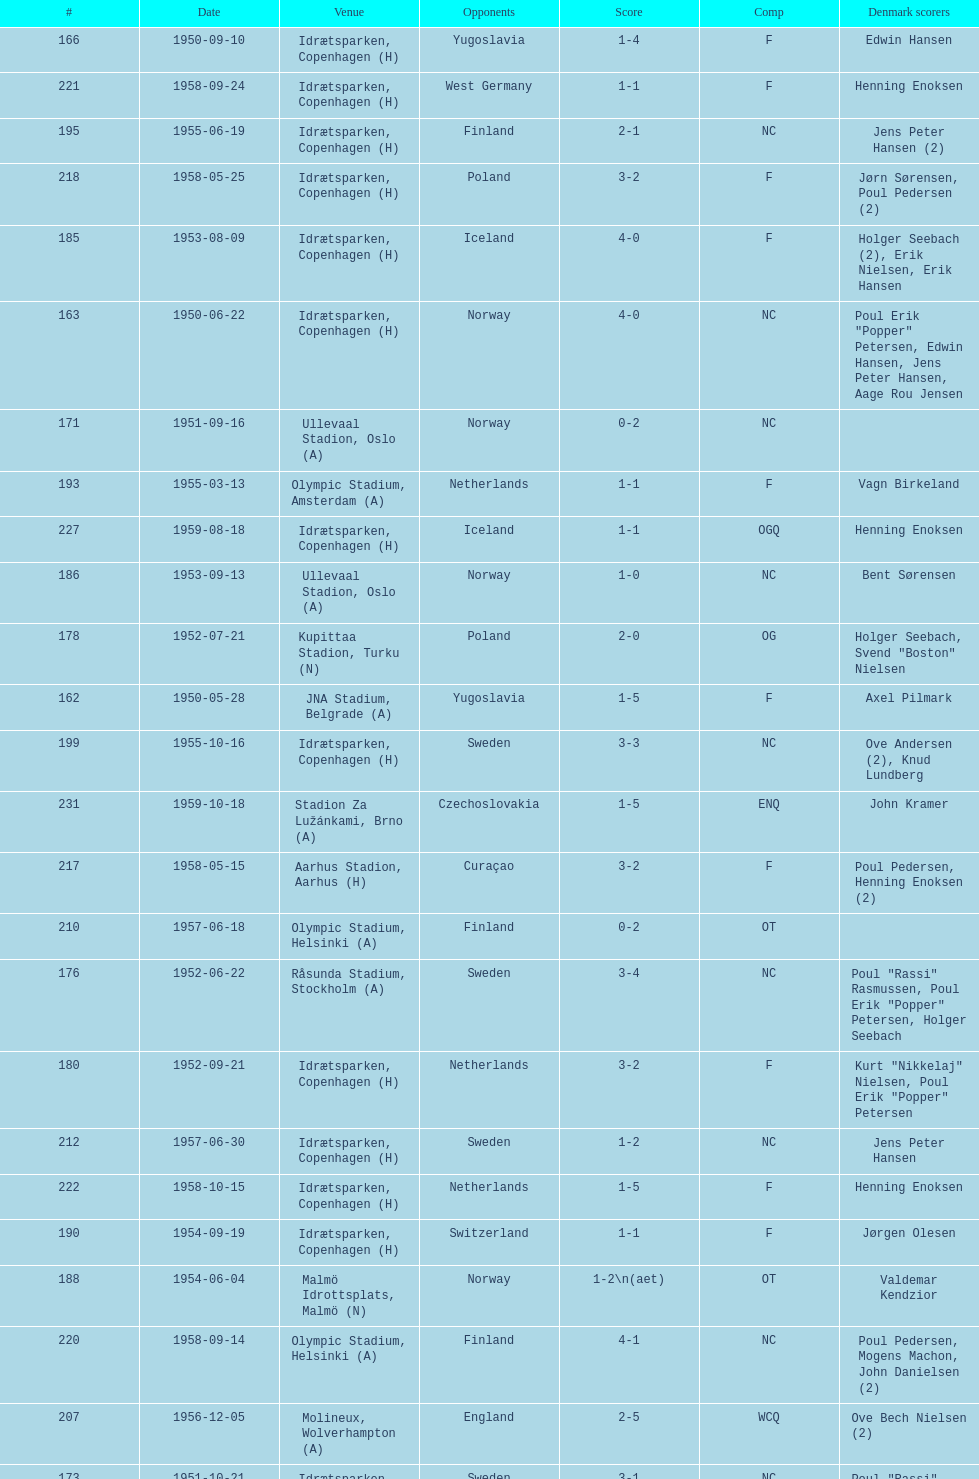What was the difference in score between the two teams in the last game? 1. 